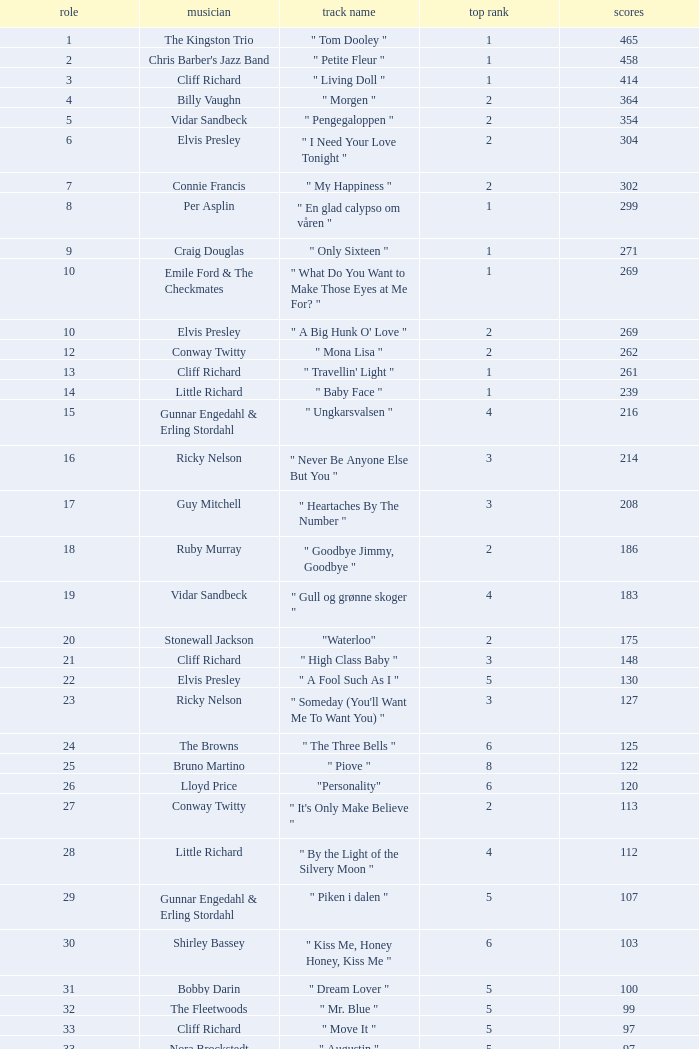What is the nme of the song performed by billy vaughn? " Morgen ". 